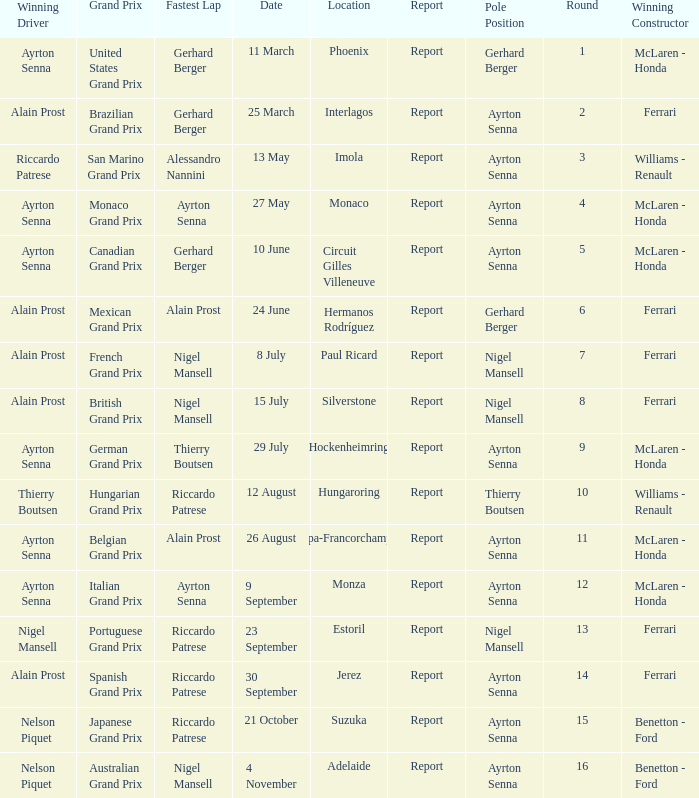What is the Pole Position for the German Grand Prix Ayrton Senna. 